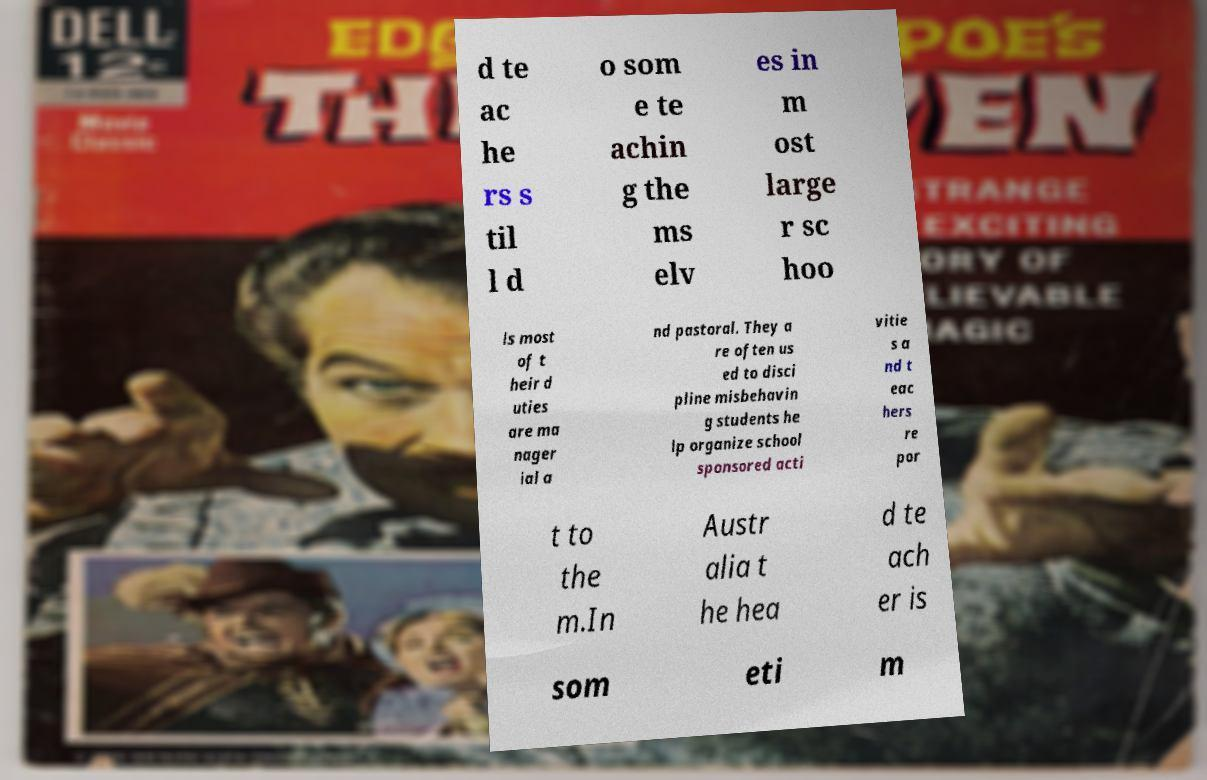Can you accurately transcribe the text from the provided image for me? d te ac he rs s til l d o som e te achin g the ms elv es in m ost large r sc hoo ls most of t heir d uties are ma nager ial a nd pastoral. They a re often us ed to disci pline misbehavin g students he lp organize school sponsored acti vitie s a nd t eac hers re por t to the m.In Austr alia t he hea d te ach er is som eti m 